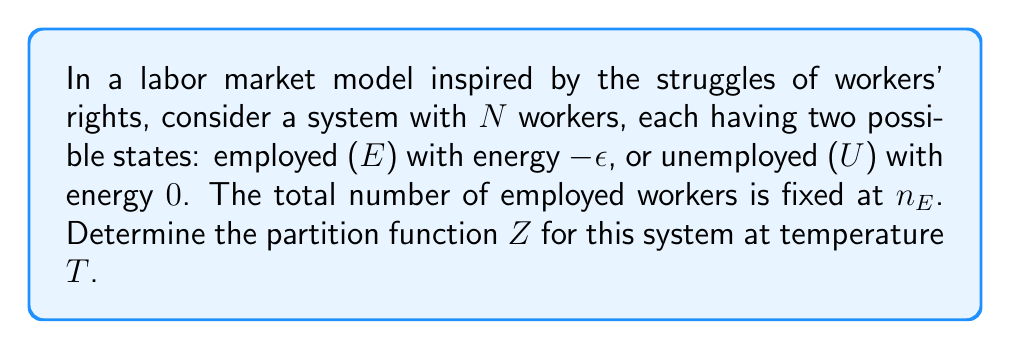Give your solution to this math problem. Let's approach this step-by-step:

1) The partition function $Z$ is defined as the sum over all possible microstates of the system:

   $$Z = \sum_{\text{all states}} e^{-\beta E}$$

   where $\beta = \frac{1}{k_B T}$, $k_B$ is Boltzmann's constant, and $E$ is the energy of a given microstate.

2) In our system, we have $n_E$ employed workers (each with energy $-\epsilon$) and $N-n_E$ unemployed workers (each with energy $0$).

3) The total energy of any microstate is:

   $$E = n_E(-\epsilon) + (N-n_E)(0) = -n_E\epsilon$$

4) Since $n_E$ is fixed, there is only one possible microstate for the system. Therefore, the partition function is simply:

   $$Z = e^{\beta n_E\epsilon}$$

5) Substituting $\beta = \frac{1}{k_B T}$:

   $$Z = e^{\frac{n_E\epsilon}{k_B T}}$$

This partition function reflects the rigid nature of this simplified labor market, where the number of employed workers is fixed, mirroring the often inflexible conditions workers face in their struggle for rights.
Answer: $$Z = e^{\frac{n_E\epsilon}{k_B T}}$$ 